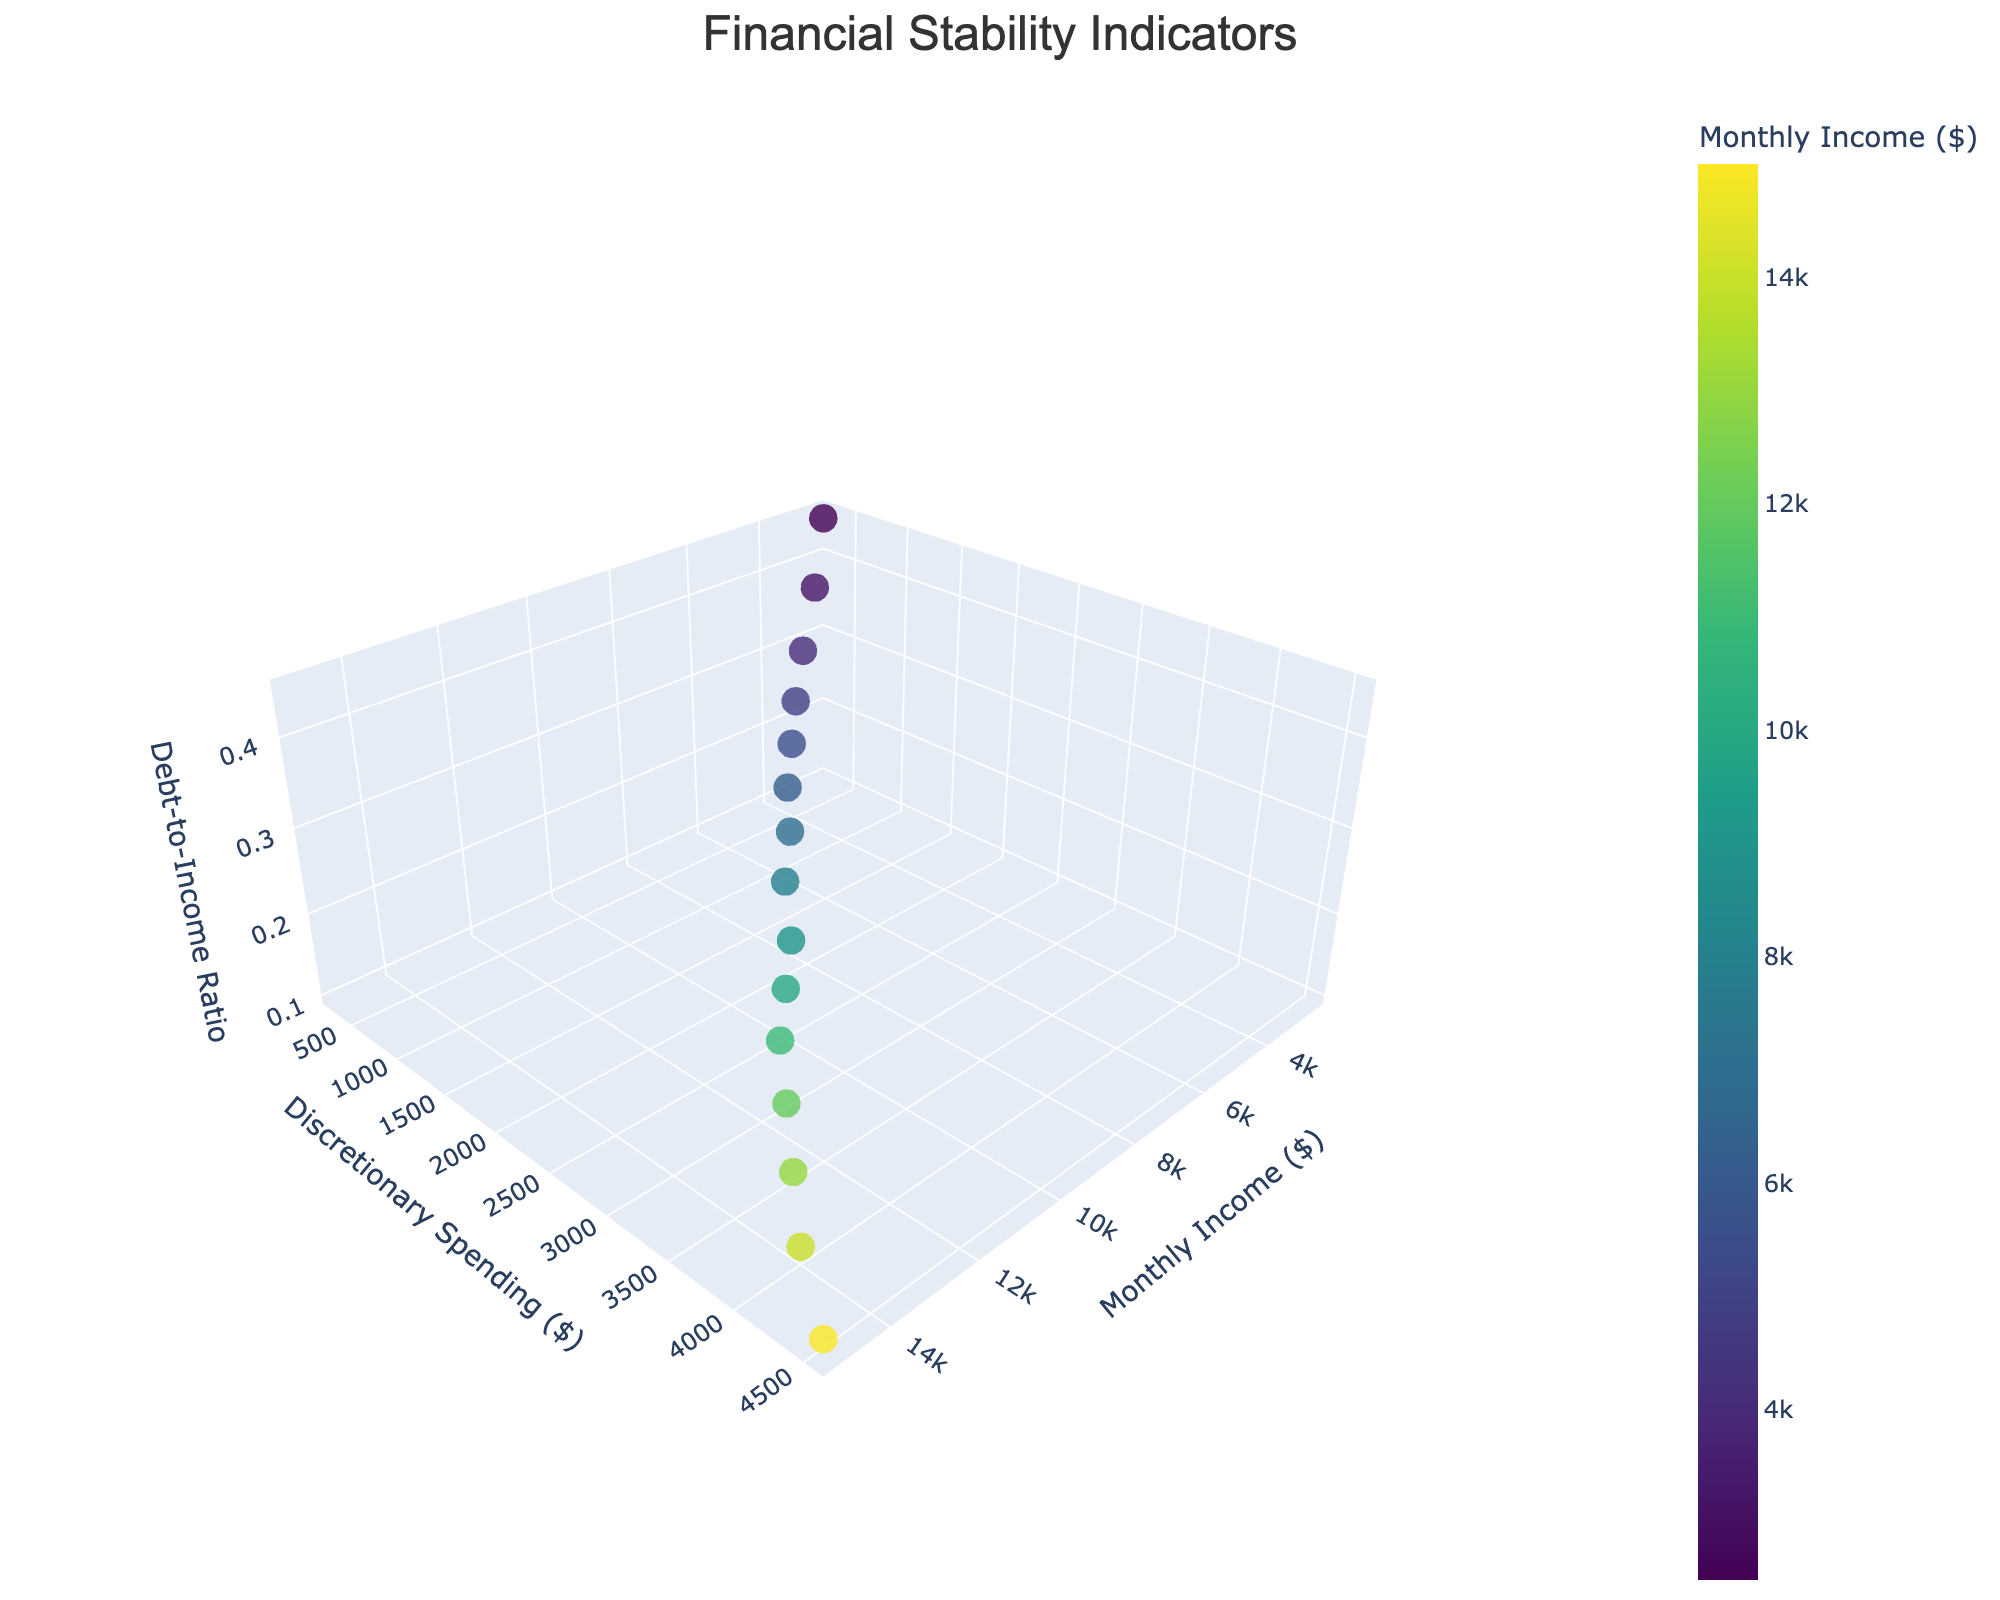What's the title of the figure? The title of the figure is usually displayed prominently at the top. By referring to this location, you would find the title "Financial Stability Indicators".
Answer: Financial Stability Indicators How many data points are there in the figure? In the figure, each marker represents a data point. Counting these markers provides the total number of data points.
Answer: 15 What's the range of Monthly Income in the figure? To find the range of Monthly Income, look for the smallest and largest values on the X-axis. It starts at $2,500 and ends at $15,000.
Answer: $2,500 to $15,000 What is the Discretionary Spending amount for the income of $9000? By locating the income of $9000 on the Monthly Income axis (X-axis) and tracking it to its corresponding marker, you find the Discretionary Spending on the Y-axis to be $2200.
Answer: $2200 Which income bracket has the highest Debt-to-Income Ratio? Inspect the Z-axis to find the highest value and locate the corresponding marker to determine the Monthly Income. The highest Debt-to-Income Ratio of 0.45 corresponds to a Monthly Income of $2500.
Answer: $2500 How does the Debt-to-Income Ratio change as Monthly Income increases? By observing the trend in the Z-axis as the X-axis values increase, the Debt-to-Income Ratio decreases consistently as Monthly Income increases.
Answer: Decreases Compare the Discretionary Spending for an income of $3200 and $6200. Locate the markers for $3200 and $6200 Monthly Income on the X-axis and compare their Y-axis values. Discretionary Spending is $450 for $3200 income and $1200 for $6200 income.
Answer: $450 vs $1200 What's the average Discretionary Spending for incomes below $5000? Sum the Discretionary Spending for incomes of $2500, $3200, $4000, and $4800, and then divide by 4: ($300 + $450 + $600 + $800) / 4 = $2150 / 4 = $537.50.
Answer: $537.50 Are there any data points where the Debt-to-Income Ratio is below 0.20? Locate the markers with Debt-to-Income Ratio on the Z-axis below 0.20. We see Monthly Incomes above $7000 have Debt-to-Income Ratios below 0.20.
Answer: Yes Compare the financial stability between the lowest and highest income brackets in terms of Debt-to-Income Ratio and Discretionary Spending. The lowest income bracket ($2500) has a Debt-to-Income Ratio of 0.45 and Discretionary Spending of $300. The highest income bracket ($15000) has a Debt-to-Income Ratio of 0.10 and Discretionary Spending of $4500. This comparison suggests better financial stability at higher income.
Answer: Higher income has better stability 